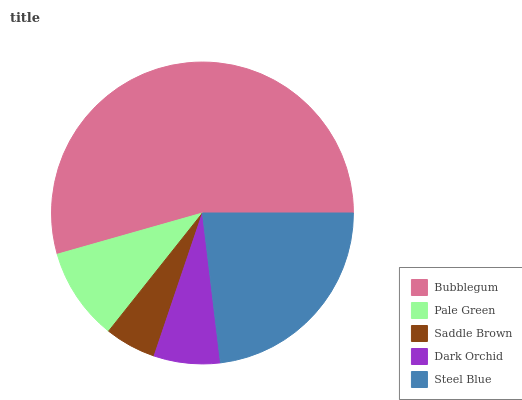Is Saddle Brown the minimum?
Answer yes or no. Yes. Is Bubblegum the maximum?
Answer yes or no. Yes. Is Pale Green the minimum?
Answer yes or no. No. Is Pale Green the maximum?
Answer yes or no. No. Is Bubblegum greater than Pale Green?
Answer yes or no. Yes. Is Pale Green less than Bubblegum?
Answer yes or no. Yes. Is Pale Green greater than Bubblegum?
Answer yes or no. No. Is Bubblegum less than Pale Green?
Answer yes or no. No. Is Pale Green the high median?
Answer yes or no. Yes. Is Pale Green the low median?
Answer yes or no. Yes. Is Bubblegum the high median?
Answer yes or no. No. Is Bubblegum the low median?
Answer yes or no. No. 